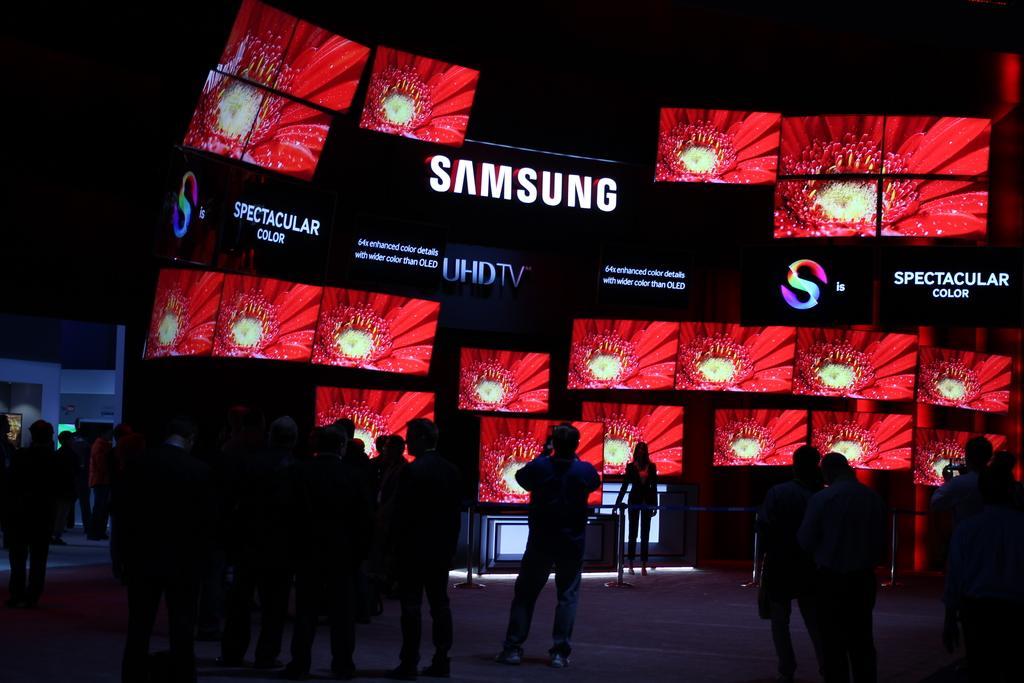In one or two sentences, can you explain what this image depicts? Here in this picture on the floor we can see number of people standing over there and in front of them we can see number of televisions displayed over there and in the middle we can see a woman standing and beside her we can see table present over there and we can see a flower present on the screens of television over there. 